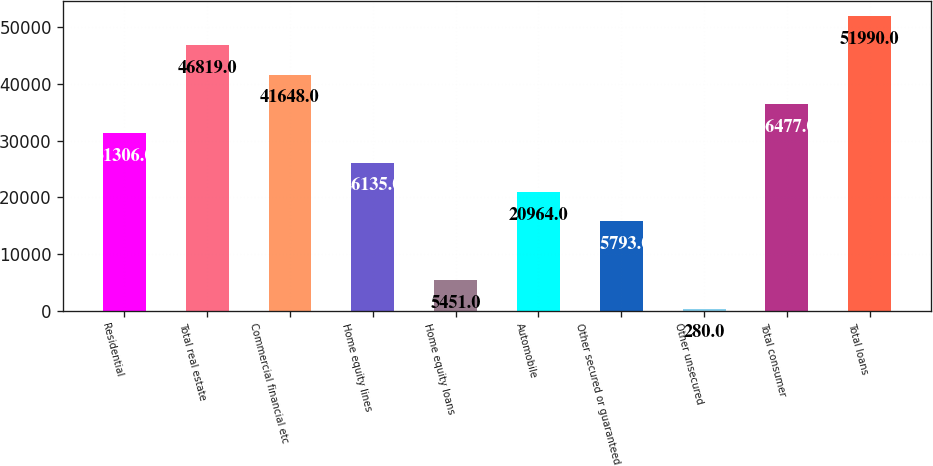Convert chart. <chart><loc_0><loc_0><loc_500><loc_500><bar_chart><fcel>Residential<fcel>Total real estate<fcel>Commercial financial etc<fcel>Home equity lines<fcel>Home equity loans<fcel>Automobile<fcel>Other secured or guaranteed<fcel>Other unsecured<fcel>Total consumer<fcel>Total loans<nl><fcel>31306<fcel>46819<fcel>41648<fcel>26135<fcel>5451<fcel>20964<fcel>15793<fcel>280<fcel>36477<fcel>51990<nl></chart> 